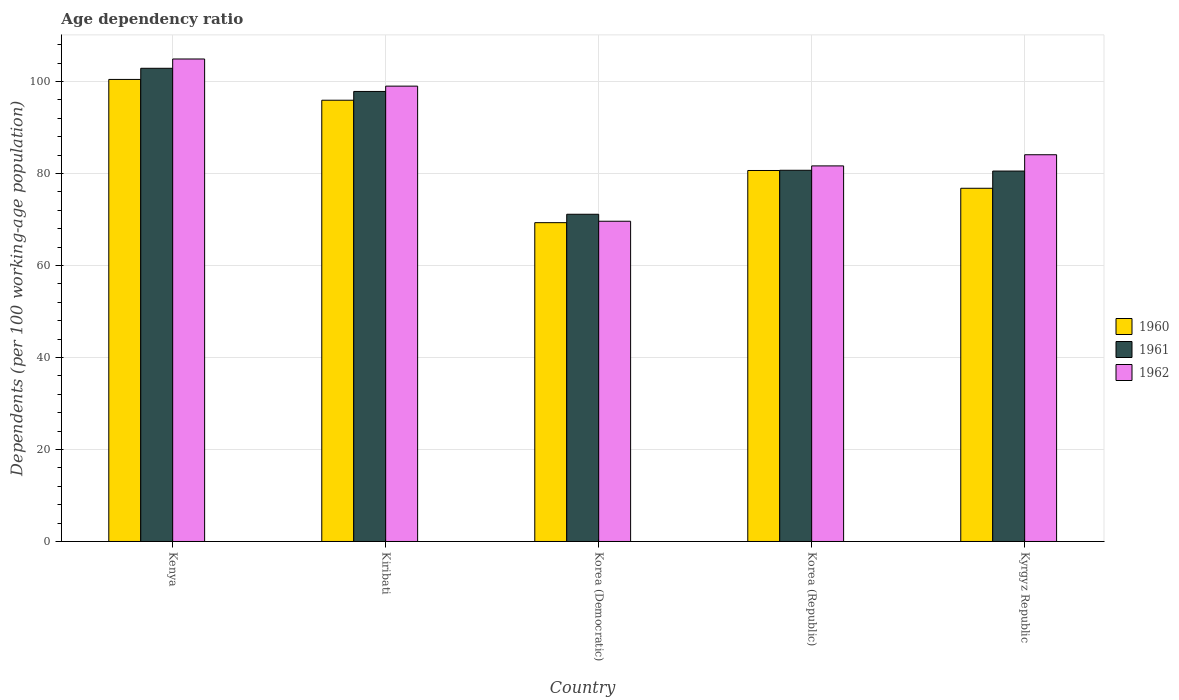Are the number of bars per tick equal to the number of legend labels?
Make the answer very short. Yes. Are the number of bars on each tick of the X-axis equal?
Provide a short and direct response. Yes. In how many cases, is the number of bars for a given country not equal to the number of legend labels?
Offer a terse response. 0. What is the age dependency ratio in in 1960 in Kyrgyz Republic?
Offer a very short reply. 76.8. Across all countries, what is the maximum age dependency ratio in in 1960?
Your answer should be compact. 100.46. Across all countries, what is the minimum age dependency ratio in in 1962?
Keep it short and to the point. 69.63. In which country was the age dependency ratio in in 1962 maximum?
Provide a succinct answer. Kenya. In which country was the age dependency ratio in in 1962 minimum?
Keep it short and to the point. Korea (Democratic). What is the total age dependency ratio in in 1960 in the graph?
Your answer should be very brief. 423.19. What is the difference between the age dependency ratio in in 1960 in Kiribati and that in Kyrgyz Republic?
Make the answer very short. 19.14. What is the difference between the age dependency ratio in in 1962 in Kenya and the age dependency ratio in in 1960 in Kyrgyz Republic?
Your response must be concise. 28.11. What is the average age dependency ratio in in 1961 per country?
Your response must be concise. 86.63. What is the difference between the age dependency ratio in of/in 1961 and age dependency ratio in of/in 1962 in Korea (Democratic)?
Provide a succinct answer. 1.52. In how many countries, is the age dependency ratio in in 1960 greater than 32 %?
Your response must be concise. 5. What is the ratio of the age dependency ratio in in 1962 in Kenya to that in Korea (Democratic)?
Offer a very short reply. 1.51. Is the difference between the age dependency ratio in in 1961 in Korea (Democratic) and Korea (Republic) greater than the difference between the age dependency ratio in in 1962 in Korea (Democratic) and Korea (Republic)?
Provide a succinct answer. Yes. What is the difference between the highest and the second highest age dependency ratio in in 1962?
Keep it short and to the point. 5.9. What is the difference between the highest and the lowest age dependency ratio in in 1962?
Ensure brevity in your answer.  35.28. In how many countries, is the age dependency ratio in in 1962 greater than the average age dependency ratio in in 1962 taken over all countries?
Offer a terse response. 2. Is the sum of the age dependency ratio in in 1962 in Korea (Democratic) and Korea (Republic) greater than the maximum age dependency ratio in in 1960 across all countries?
Your response must be concise. Yes. What does the 2nd bar from the left in Korea (Democratic) represents?
Your answer should be very brief. 1961. Are all the bars in the graph horizontal?
Your answer should be compact. No. How many countries are there in the graph?
Provide a short and direct response. 5. Are the values on the major ticks of Y-axis written in scientific E-notation?
Your response must be concise. No. How many legend labels are there?
Your answer should be very brief. 3. How are the legend labels stacked?
Provide a succinct answer. Vertical. What is the title of the graph?
Offer a very short reply. Age dependency ratio. What is the label or title of the X-axis?
Ensure brevity in your answer.  Country. What is the label or title of the Y-axis?
Your response must be concise. Dependents (per 100 working-age population). What is the Dependents (per 100 working-age population) of 1960 in Kenya?
Offer a very short reply. 100.46. What is the Dependents (per 100 working-age population) in 1961 in Kenya?
Offer a terse response. 102.89. What is the Dependents (per 100 working-age population) of 1962 in Kenya?
Your response must be concise. 104.91. What is the Dependents (per 100 working-age population) in 1960 in Kiribati?
Your response must be concise. 95.94. What is the Dependents (per 100 working-age population) in 1961 in Kiribati?
Offer a very short reply. 97.85. What is the Dependents (per 100 working-age population) in 1962 in Kiribati?
Your answer should be compact. 99.01. What is the Dependents (per 100 working-age population) in 1960 in Korea (Democratic)?
Make the answer very short. 69.32. What is the Dependents (per 100 working-age population) in 1961 in Korea (Democratic)?
Keep it short and to the point. 71.15. What is the Dependents (per 100 working-age population) in 1962 in Korea (Democratic)?
Provide a short and direct response. 69.63. What is the Dependents (per 100 working-age population) of 1960 in Korea (Republic)?
Your answer should be very brief. 80.67. What is the Dependents (per 100 working-age population) in 1961 in Korea (Republic)?
Your response must be concise. 80.71. What is the Dependents (per 100 working-age population) in 1962 in Korea (Republic)?
Offer a terse response. 81.67. What is the Dependents (per 100 working-age population) of 1960 in Kyrgyz Republic?
Your answer should be compact. 76.8. What is the Dependents (per 100 working-age population) in 1961 in Kyrgyz Republic?
Ensure brevity in your answer.  80.54. What is the Dependents (per 100 working-age population) of 1962 in Kyrgyz Republic?
Offer a very short reply. 84.09. Across all countries, what is the maximum Dependents (per 100 working-age population) of 1960?
Your response must be concise. 100.46. Across all countries, what is the maximum Dependents (per 100 working-age population) of 1961?
Offer a very short reply. 102.89. Across all countries, what is the maximum Dependents (per 100 working-age population) in 1962?
Ensure brevity in your answer.  104.91. Across all countries, what is the minimum Dependents (per 100 working-age population) in 1960?
Ensure brevity in your answer.  69.32. Across all countries, what is the minimum Dependents (per 100 working-age population) of 1961?
Make the answer very short. 71.15. Across all countries, what is the minimum Dependents (per 100 working-age population) in 1962?
Give a very brief answer. 69.63. What is the total Dependents (per 100 working-age population) of 1960 in the graph?
Offer a terse response. 423.19. What is the total Dependents (per 100 working-age population) in 1961 in the graph?
Provide a succinct answer. 433.14. What is the total Dependents (per 100 working-age population) of 1962 in the graph?
Your answer should be very brief. 439.3. What is the difference between the Dependents (per 100 working-age population) in 1960 in Kenya and that in Kiribati?
Give a very brief answer. 4.52. What is the difference between the Dependents (per 100 working-age population) in 1961 in Kenya and that in Kiribati?
Offer a terse response. 5.04. What is the difference between the Dependents (per 100 working-age population) in 1962 in Kenya and that in Kiribati?
Offer a terse response. 5.9. What is the difference between the Dependents (per 100 working-age population) of 1960 in Kenya and that in Korea (Democratic)?
Make the answer very short. 31.14. What is the difference between the Dependents (per 100 working-age population) in 1961 in Kenya and that in Korea (Democratic)?
Your answer should be very brief. 31.74. What is the difference between the Dependents (per 100 working-age population) of 1962 in Kenya and that in Korea (Democratic)?
Provide a short and direct response. 35.28. What is the difference between the Dependents (per 100 working-age population) of 1960 in Kenya and that in Korea (Republic)?
Provide a short and direct response. 19.8. What is the difference between the Dependents (per 100 working-age population) of 1961 in Kenya and that in Korea (Republic)?
Make the answer very short. 22.18. What is the difference between the Dependents (per 100 working-age population) in 1962 in Kenya and that in Korea (Republic)?
Keep it short and to the point. 23.24. What is the difference between the Dependents (per 100 working-age population) in 1960 in Kenya and that in Kyrgyz Republic?
Offer a very short reply. 23.66. What is the difference between the Dependents (per 100 working-age population) of 1961 in Kenya and that in Kyrgyz Republic?
Make the answer very short. 22.35. What is the difference between the Dependents (per 100 working-age population) in 1962 in Kenya and that in Kyrgyz Republic?
Provide a short and direct response. 20.82. What is the difference between the Dependents (per 100 working-age population) of 1960 in Kiribati and that in Korea (Democratic)?
Your response must be concise. 26.62. What is the difference between the Dependents (per 100 working-age population) of 1961 in Kiribati and that in Korea (Democratic)?
Offer a terse response. 26.7. What is the difference between the Dependents (per 100 working-age population) of 1962 in Kiribati and that in Korea (Democratic)?
Provide a succinct answer. 29.38. What is the difference between the Dependents (per 100 working-age population) of 1960 in Kiribati and that in Korea (Republic)?
Your answer should be very brief. 15.28. What is the difference between the Dependents (per 100 working-age population) of 1961 in Kiribati and that in Korea (Republic)?
Give a very brief answer. 17.14. What is the difference between the Dependents (per 100 working-age population) in 1962 in Kiribati and that in Korea (Republic)?
Your answer should be compact. 17.34. What is the difference between the Dependents (per 100 working-age population) in 1960 in Kiribati and that in Kyrgyz Republic?
Offer a very short reply. 19.14. What is the difference between the Dependents (per 100 working-age population) of 1961 in Kiribati and that in Kyrgyz Republic?
Your answer should be very brief. 17.31. What is the difference between the Dependents (per 100 working-age population) of 1962 in Kiribati and that in Kyrgyz Republic?
Give a very brief answer. 14.92. What is the difference between the Dependents (per 100 working-age population) in 1960 in Korea (Democratic) and that in Korea (Republic)?
Provide a succinct answer. -11.34. What is the difference between the Dependents (per 100 working-age population) in 1961 in Korea (Democratic) and that in Korea (Republic)?
Your answer should be very brief. -9.56. What is the difference between the Dependents (per 100 working-age population) of 1962 in Korea (Democratic) and that in Korea (Republic)?
Keep it short and to the point. -12.03. What is the difference between the Dependents (per 100 working-age population) of 1960 in Korea (Democratic) and that in Kyrgyz Republic?
Offer a terse response. -7.48. What is the difference between the Dependents (per 100 working-age population) of 1961 in Korea (Democratic) and that in Kyrgyz Republic?
Provide a short and direct response. -9.4. What is the difference between the Dependents (per 100 working-age population) in 1962 in Korea (Democratic) and that in Kyrgyz Republic?
Offer a terse response. -14.46. What is the difference between the Dependents (per 100 working-age population) of 1960 in Korea (Republic) and that in Kyrgyz Republic?
Your answer should be compact. 3.86. What is the difference between the Dependents (per 100 working-age population) in 1961 in Korea (Republic) and that in Kyrgyz Republic?
Offer a terse response. 0.17. What is the difference between the Dependents (per 100 working-age population) in 1962 in Korea (Republic) and that in Kyrgyz Republic?
Make the answer very short. -2.43. What is the difference between the Dependents (per 100 working-age population) in 1960 in Kenya and the Dependents (per 100 working-age population) in 1961 in Kiribati?
Offer a terse response. 2.61. What is the difference between the Dependents (per 100 working-age population) in 1960 in Kenya and the Dependents (per 100 working-age population) in 1962 in Kiribati?
Give a very brief answer. 1.46. What is the difference between the Dependents (per 100 working-age population) in 1961 in Kenya and the Dependents (per 100 working-age population) in 1962 in Kiribati?
Keep it short and to the point. 3.88. What is the difference between the Dependents (per 100 working-age population) of 1960 in Kenya and the Dependents (per 100 working-age population) of 1961 in Korea (Democratic)?
Give a very brief answer. 29.32. What is the difference between the Dependents (per 100 working-age population) in 1960 in Kenya and the Dependents (per 100 working-age population) in 1962 in Korea (Democratic)?
Offer a very short reply. 30.83. What is the difference between the Dependents (per 100 working-age population) of 1961 in Kenya and the Dependents (per 100 working-age population) of 1962 in Korea (Democratic)?
Your response must be concise. 33.26. What is the difference between the Dependents (per 100 working-age population) of 1960 in Kenya and the Dependents (per 100 working-age population) of 1961 in Korea (Republic)?
Ensure brevity in your answer.  19.75. What is the difference between the Dependents (per 100 working-age population) in 1960 in Kenya and the Dependents (per 100 working-age population) in 1962 in Korea (Republic)?
Give a very brief answer. 18.8. What is the difference between the Dependents (per 100 working-age population) of 1961 in Kenya and the Dependents (per 100 working-age population) of 1962 in Korea (Republic)?
Provide a short and direct response. 21.22. What is the difference between the Dependents (per 100 working-age population) in 1960 in Kenya and the Dependents (per 100 working-age population) in 1961 in Kyrgyz Republic?
Your response must be concise. 19.92. What is the difference between the Dependents (per 100 working-age population) in 1960 in Kenya and the Dependents (per 100 working-age population) in 1962 in Kyrgyz Republic?
Provide a succinct answer. 16.37. What is the difference between the Dependents (per 100 working-age population) in 1961 in Kenya and the Dependents (per 100 working-age population) in 1962 in Kyrgyz Republic?
Your response must be concise. 18.8. What is the difference between the Dependents (per 100 working-age population) of 1960 in Kiribati and the Dependents (per 100 working-age population) of 1961 in Korea (Democratic)?
Give a very brief answer. 24.79. What is the difference between the Dependents (per 100 working-age population) in 1960 in Kiribati and the Dependents (per 100 working-age population) in 1962 in Korea (Democratic)?
Provide a short and direct response. 26.31. What is the difference between the Dependents (per 100 working-age population) of 1961 in Kiribati and the Dependents (per 100 working-age population) of 1962 in Korea (Democratic)?
Keep it short and to the point. 28.22. What is the difference between the Dependents (per 100 working-age population) of 1960 in Kiribati and the Dependents (per 100 working-age population) of 1961 in Korea (Republic)?
Your answer should be compact. 15.23. What is the difference between the Dependents (per 100 working-age population) in 1960 in Kiribati and the Dependents (per 100 working-age population) in 1962 in Korea (Republic)?
Make the answer very short. 14.28. What is the difference between the Dependents (per 100 working-age population) of 1961 in Kiribati and the Dependents (per 100 working-age population) of 1962 in Korea (Republic)?
Offer a very short reply. 16.19. What is the difference between the Dependents (per 100 working-age population) in 1960 in Kiribati and the Dependents (per 100 working-age population) in 1961 in Kyrgyz Republic?
Your response must be concise. 15.4. What is the difference between the Dependents (per 100 working-age population) in 1960 in Kiribati and the Dependents (per 100 working-age population) in 1962 in Kyrgyz Republic?
Your answer should be compact. 11.85. What is the difference between the Dependents (per 100 working-age population) of 1961 in Kiribati and the Dependents (per 100 working-age population) of 1962 in Kyrgyz Republic?
Your answer should be very brief. 13.76. What is the difference between the Dependents (per 100 working-age population) of 1960 in Korea (Democratic) and the Dependents (per 100 working-age population) of 1961 in Korea (Republic)?
Offer a terse response. -11.39. What is the difference between the Dependents (per 100 working-age population) of 1960 in Korea (Democratic) and the Dependents (per 100 working-age population) of 1962 in Korea (Republic)?
Give a very brief answer. -12.34. What is the difference between the Dependents (per 100 working-age population) in 1961 in Korea (Democratic) and the Dependents (per 100 working-age population) in 1962 in Korea (Republic)?
Ensure brevity in your answer.  -10.52. What is the difference between the Dependents (per 100 working-age population) in 1960 in Korea (Democratic) and the Dependents (per 100 working-age population) in 1961 in Kyrgyz Republic?
Offer a terse response. -11.22. What is the difference between the Dependents (per 100 working-age population) of 1960 in Korea (Democratic) and the Dependents (per 100 working-age population) of 1962 in Kyrgyz Republic?
Make the answer very short. -14.77. What is the difference between the Dependents (per 100 working-age population) in 1961 in Korea (Democratic) and the Dependents (per 100 working-age population) in 1962 in Kyrgyz Republic?
Your response must be concise. -12.94. What is the difference between the Dependents (per 100 working-age population) of 1960 in Korea (Republic) and the Dependents (per 100 working-age population) of 1961 in Kyrgyz Republic?
Ensure brevity in your answer.  0.12. What is the difference between the Dependents (per 100 working-age population) of 1960 in Korea (Republic) and the Dependents (per 100 working-age population) of 1962 in Kyrgyz Republic?
Your answer should be compact. -3.42. What is the difference between the Dependents (per 100 working-age population) in 1961 in Korea (Republic) and the Dependents (per 100 working-age population) in 1962 in Kyrgyz Republic?
Make the answer very short. -3.38. What is the average Dependents (per 100 working-age population) of 1960 per country?
Keep it short and to the point. 84.64. What is the average Dependents (per 100 working-age population) in 1961 per country?
Your response must be concise. 86.63. What is the average Dependents (per 100 working-age population) of 1962 per country?
Keep it short and to the point. 87.86. What is the difference between the Dependents (per 100 working-age population) of 1960 and Dependents (per 100 working-age population) of 1961 in Kenya?
Keep it short and to the point. -2.42. What is the difference between the Dependents (per 100 working-age population) in 1960 and Dependents (per 100 working-age population) in 1962 in Kenya?
Your answer should be very brief. -4.44. What is the difference between the Dependents (per 100 working-age population) of 1961 and Dependents (per 100 working-age population) of 1962 in Kenya?
Provide a succinct answer. -2.02. What is the difference between the Dependents (per 100 working-age population) of 1960 and Dependents (per 100 working-age population) of 1961 in Kiribati?
Your answer should be compact. -1.91. What is the difference between the Dependents (per 100 working-age population) in 1960 and Dependents (per 100 working-age population) in 1962 in Kiribati?
Provide a succinct answer. -3.07. What is the difference between the Dependents (per 100 working-age population) of 1961 and Dependents (per 100 working-age population) of 1962 in Kiribati?
Your answer should be very brief. -1.16. What is the difference between the Dependents (per 100 working-age population) of 1960 and Dependents (per 100 working-age population) of 1961 in Korea (Democratic)?
Offer a very short reply. -1.83. What is the difference between the Dependents (per 100 working-age population) in 1960 and Dependents (per 100 working-age population) in 1962 in Korea (Democratic)?
Your response must be concise. -0.31. What is the difference between the Dependents (per 100 working-age population) in 1961 and Dependents (per 100 working-age population) in 1962 in Korea (Democratic)?
Give a very brief answer. 1.52. What is the difference between the Dependents (per 100 working-age population) of 1960 and Dependents (per 100 working-age population) of 1961 in Korea (Republic)?
Your answer should be very brief. -0.05. What is the difference between the Dependents (per 100 working-age population) in 1960 and Dependents (per 100 working-age population) in 1962 in Korea (Republic)?
Keep it short and to the point. -1. What is the difference between the Dependents (per 100 working-age population) of 1961 and Dependents (per 100 working-age population) of 1962 in Korea (Republic)?
Provide a short and direct response. -0.95. What is the difference between the Dependents (per 100 working-age population) in 1960 and Dependents (per 100 working-age population) in 1961 in Kyrgyz Republic?
Your answer should be compact. -3.74. What is the difference between the Dependents (per 100 working-age population) in 1960 and Dependents (per 100 working-age population) in 1962 in Kyrgyz Republic?
Ensure brevity in your answer.  -7.29. What is the difference between the Dependents (per 100 working-age population) in 1961 and Dependents (per 100 working-age population) in 1962 in Kyrgyz Republic?
Offer a terse response. -3.55. What is the ratio of the Dependents (per 100 working-age population) in 1960 in Kenya to that in Kiribati?
Your answer should be compact. 1.05. What is the ratio of the Dependents (per 100 working-age population) in 1961 in Kenya to that in Kiribati?
Your answer should be very brief. 1.05. What is the ratio of the Dependents (per 100 working-age population) in 1962 in Kenya to that in Kiribati?
Offer a very short reply. 1.06. What is the ratio of the Dependents (per 100 working-age population) of 1960 in Kenya to that in Korea (Democratic)?
Your response must be concise. 1.45. What is the ratio of the Dependents (per 100 working-age population) of 1961 in Kenya to that in Korea (Democratic)?
Your response must be concise. 1.45. What is the ratio of the Dependents (per 100 working-age population) of 1962 in Kenya to that in Korea (Democratic)?
Provide a succinct answer. 1.51. What is the ratio of the Dependents (per 100 working-age population) of 1960 in Kenya to that in Korea (Republic)?
Give a very brief answer. 1.25. What is the ratio of the Dependents (per 100 working-age population) of 1961 in Kenya to that in Korea (Republic)?
Your response must be concise. 1.27. What is the ratio of the Dependents (per 100 working-age population) of 1962 in Kenya to that in Korea (Republic)?
Your response must be concise. 1.28. What is the ratio of the Dependents (per 100 working-age population) in 1960 in Kenya to that in Kyrgyz Republic?
Your answer should be very brief. 1.31. What is the ratio of the Dependents (per 100 working-age population) in 1961 in Kenya to that in Kyrgyz Republic?
Provide a short and direct response. 1.28. What is the ratio of the Dependents (per 100 working-age population) in 1962 in Kenya to that in Kyrgyz Republic?
Give a very brief answer. 1.25. What is the ratio of the Dependents (per 100 working-age population) in 1960 in Kiribati to that in Korea (Democratic)?
Provide a short and direct response. 1.38. What is the ratio of the Dependents (per 100 working-age population) of 1961 in Kiribati to that in Korea (Democratic)?
Provide a succinct answer. 1.38. What is the ratio of the Dependents (per 100 working-age population) in 1962 in Kiribati to that in Korea (Democratic)?
Your answer should be compact. 1.42. What is the ratio of the Dependents (per 100 working-age population) in 1960 in Kiribati to that in Korea (Republic)?
Your answer should be very brief. 1.19. What is the ratio of the Dependents (per 100 working-age population) of 1961 in Kiribati to that in Korea (Republic)?
Provide a succinct answer. 1.21. What is the ratio of the Dependents (per 100 working-age population) in 1962 in Kiribati to that in Korea (Republic)?
Ensure brevity in your answer.  1.21. What is the ratio of the Dependents (per 100 working-age population) of 1960 in Kiribati to that in Kyrgyz Republic?
Offer a very short reply. 1.25. What is the ratio of the Dependents (per 100 working-age population) in 1961 in Kiribati to that in Kyrgyz Republic?
Make the answer very short. 1.21. What is the ratio of the Dependents (per 100 working-age population) in 1962 in Kiribati to that in Kyrgyz Republic?
Ensure brevity in your answer.  1.18. What is the ratio of the Dependents (per 100 working-age population) in 1960 in Korea (Democratic) to that in Korea (Republic)?
Make the answer very short. 0.86. What is the ratio of the Dependents (per 100 working-age population) in 1961 in Korea (Democratic) to that in Korea (Republic)?
Offer a terse response. 0.88. What is the ratio of the Dependents (per 100 working-age population) of 1962 in Korea (Democratic) to that in Korea (Republic)?
Provide a short and direct response. 0.85. What is the ratio of the Dependents (per 100 working-age population) in 1960 in Korea (Democratic) to that in Kyrgyz Republic?
Ensure brevity in your answer.  0.9. What is the ratio of the Dependents (per 100 working-age population) of 1961 in Korea (Democratic) to that in Kyrgyz Republic?
Make the answer very short. 0.88. What is the ratio of the Dependents (per 100 working-age population) of 1962 in Korea (Democratic) to that in Kyrgyz Republic?
Your response must be concise. 0.83. What is the ratio of the Dependents (per 100 working-age population) of 1960 in Korea (Republic) to that in Kyrgyz Republic?
Ensure brevity in your answer.  1.05. What is the ratio of the Dependents (per 100 working-age population) of 1961 in Korea (Republic) to that in Kyrgyz Republic?
Offer a very short reply. 1. What is the ratio of the Dependents (per 100 working-age population) of 1962 in Korea (Republic) to that in Kyrgyz Republic?
Your answer should be very brief. 0.97. What is the difference between the highest and the second highest Dependents (per 100 working-age population) of 1960?
Make the answer very short. 4.52. What is the difference between the highest and the second highest Dependents (per 100 working-age population) of 1961?
Your response must be concise. 5.04. What is the difference between the highest and the second highest Dependents (per 100 working-age population) of 1962?
Offer a terse response. 5.9. What is the difference between the highest and the lowest Dependents (per 100 working-age population) of 1960?
Give a very brief answer. 31.14. What is the difference between the highest and the lowest Dependents (per 100 working-age population) of 1961?
Give a very brief answer. 31.74. What is the difference between the highest and the lowest Dependents (per 100 working-age population) in 1962?
Give a very brief answer. 35.28. 